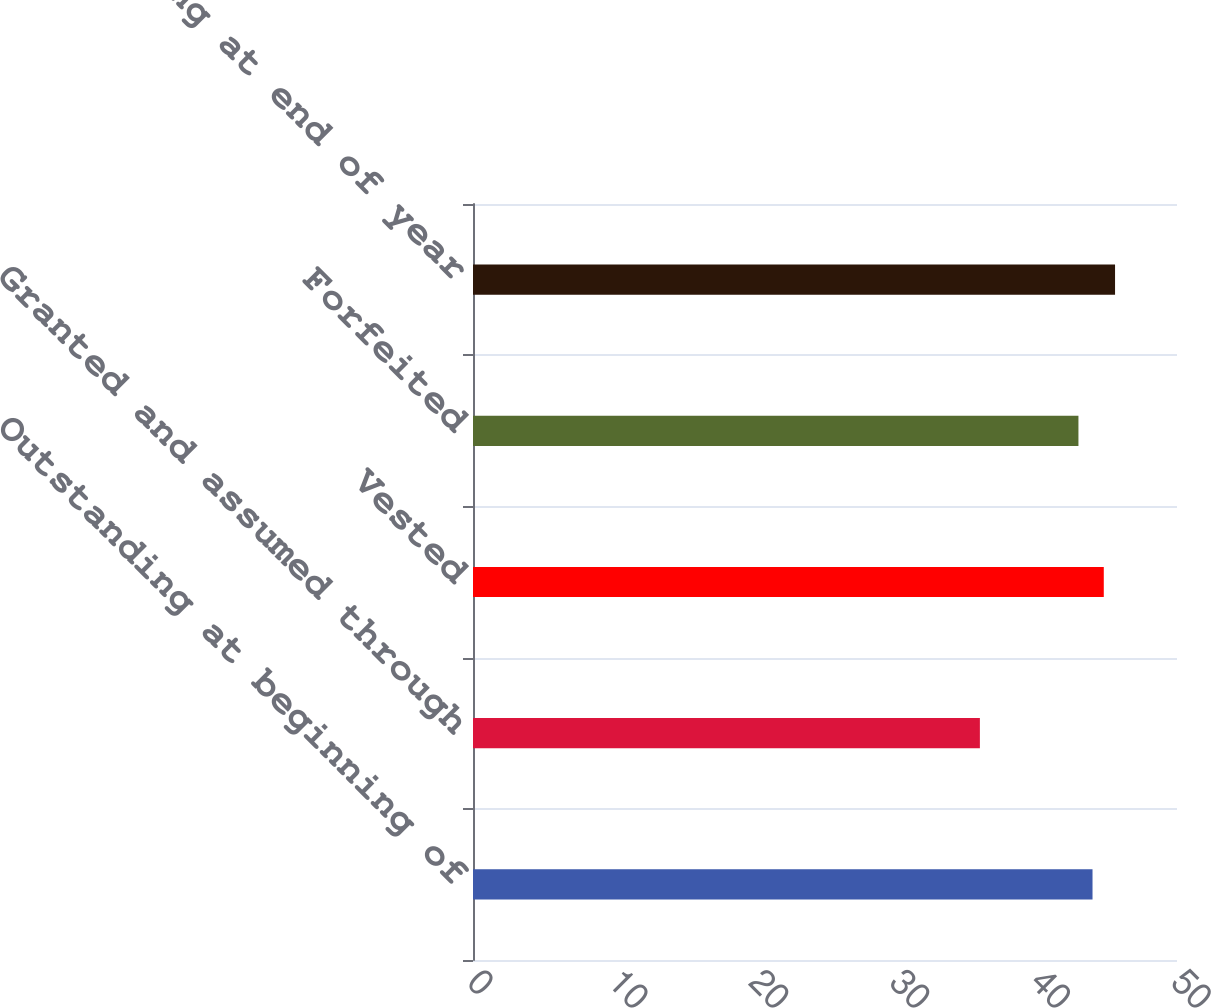<chart> <loc_0><loc_0><loc_500><loc_500><bar_chart><fcel>Outstanding at beginning of<fcel>Granted and assumed through<fcel>Vested<fcel>Forfeited<fcel>Outstanding at end of year<nl><fcel>44<fcel>36<fcel>44.8<fcel>43<fcel>45.6<nl></chart> 